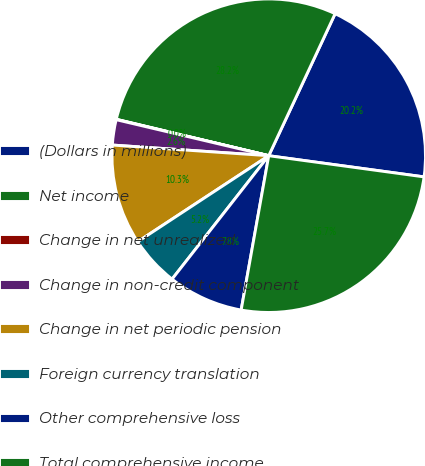Convert chart to OTSL. <chart><loc_0><loc_0><loc_500><loc_500><pie_chart><fcel>(Dollars in millions)<fcel>Net income<fcel>Change in net unrealized<fcel>Change in non-credit component<fcel>Change in net periodic pension<fcel>Foreign currency translation<fcel>Other comprehensive loss<fcel>Total comprehensive income<nl><fcel>20.2%<fcel>28.23%<fcel>0.04%<fcel>2.61%<fcel>10.33%<fcel>5.18%<fcel>7.76%<fcel>25.66%<nl></chart> 